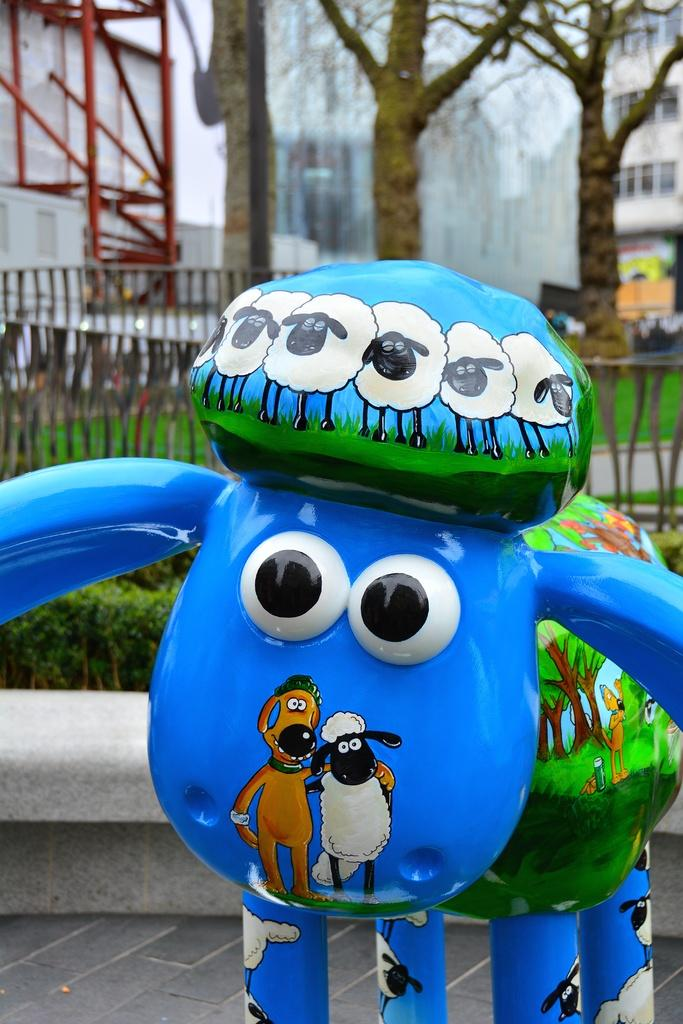What is the main object in the foreground of the image? There is a toy statue in the foreground of the image. What is located behind the toy statue? There are plants behind the toy statue. What architectural feature can be seen in the image? There is a railing visible in the image. What type of vegetation is visible in the background of the image? There are trees in the background of the image. What type of structures can be seen in the distance? There are buildings in the background of the image. What type of soap is being used to clean the toy statue in the image? There is no soap or cleaning activity depicted in the image; it features a toy statue with plants, a railing, trees, and buildings in the background. 